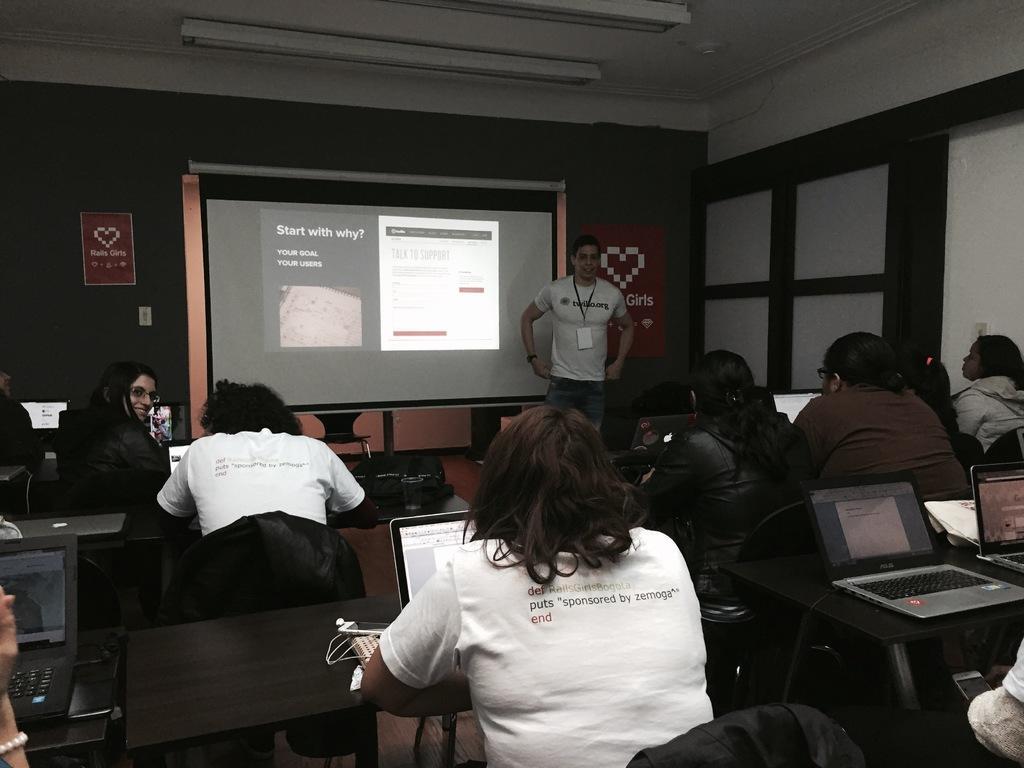Please provide a concise description of this image. In this image we can see a group of people sitting on the benches and the laptops which are placed on the tables. On the backside we can see a man standing beside a display screen containing some text on it. We can also see some papers on a wall and a roof with some ceiling lights. 